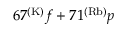Convert formula to latex. <formula><loc_0><loc_0><loc_500><loc_500>6 7 ^ { ( K ) } f + 7 1 ^ { ( R b ) } p</formula> 